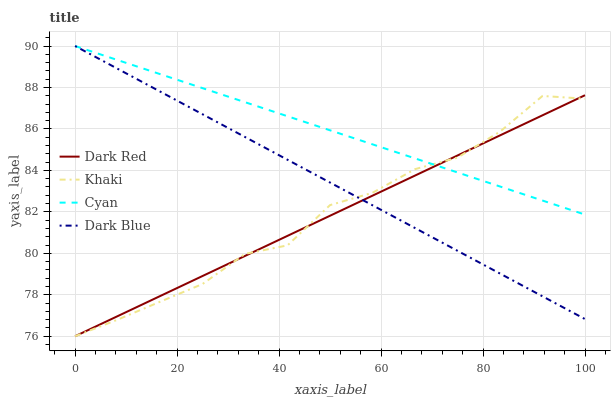Does Dark Red have the minimum area under the curve?
Answer yes or no. Yes. Does Cyan have the maximum area under the curve?
Answer yes or no. Yes. Does Khaki have the minimum area under the curve?
Answer yes or no. No. Does Khaki have the maximum area under the curve?
Answer yes or no. No. Is Dark Blue the smoothest?
Answer yes or no. Yes. Is Khaki the roughest?
Answer yes or no. Yes. Is Khaki the smoothest?
Answer yes or no. No. Is Dark Blue the roughest?
Answer yes or no. No. Does Dark Red have the lowest value?
Answer yes or no. Yes. Does Dark Blue have the lowest value?
Answer yes or no. No. Does Cyan have the highest value?
Answer yes or no. Yes. Does Khaki have the highest value?
Answer yes or no. No. Does Dark Red intersect Dark Blue?
Answer yes or no. Yes. Is Dark Red less than Dark Blue?
Answer yes or no. No. Is Dark Red greater than Dark Blue?
Answer yes or no. No. 